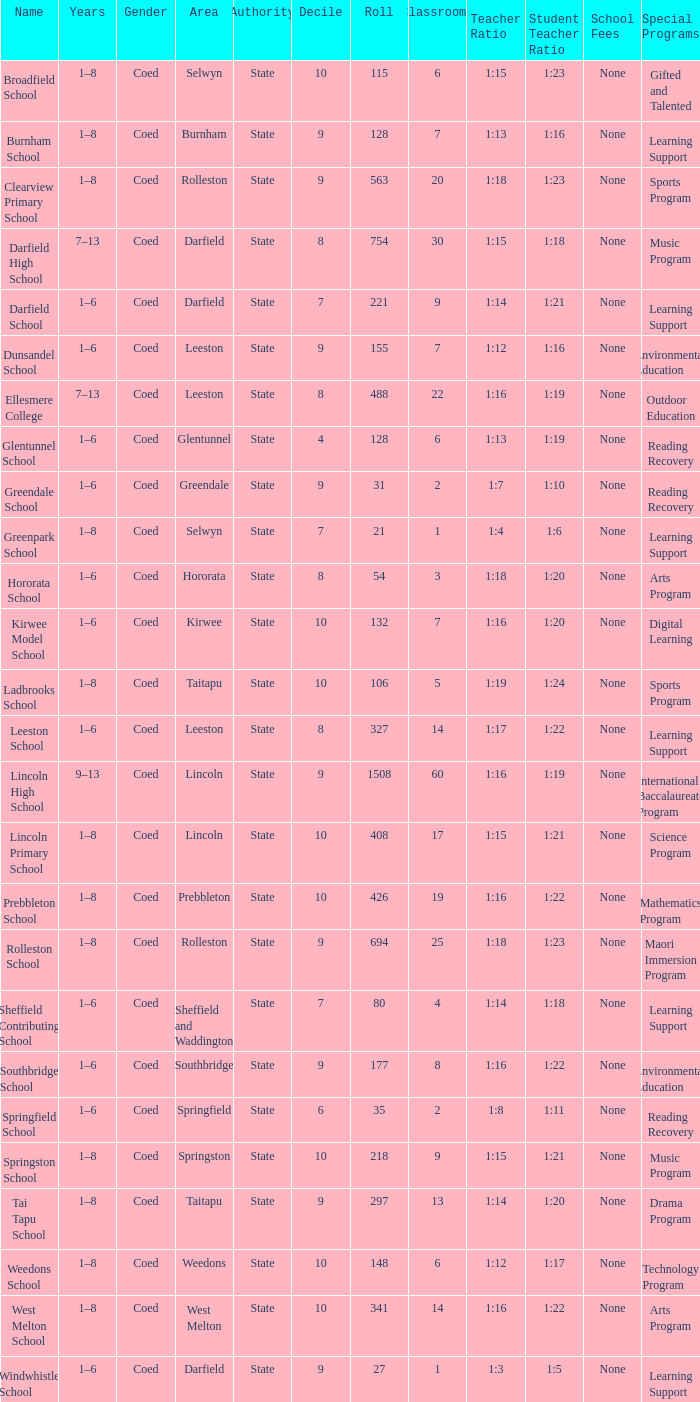Which years have a Name of ladbrooks school? 1–8. 